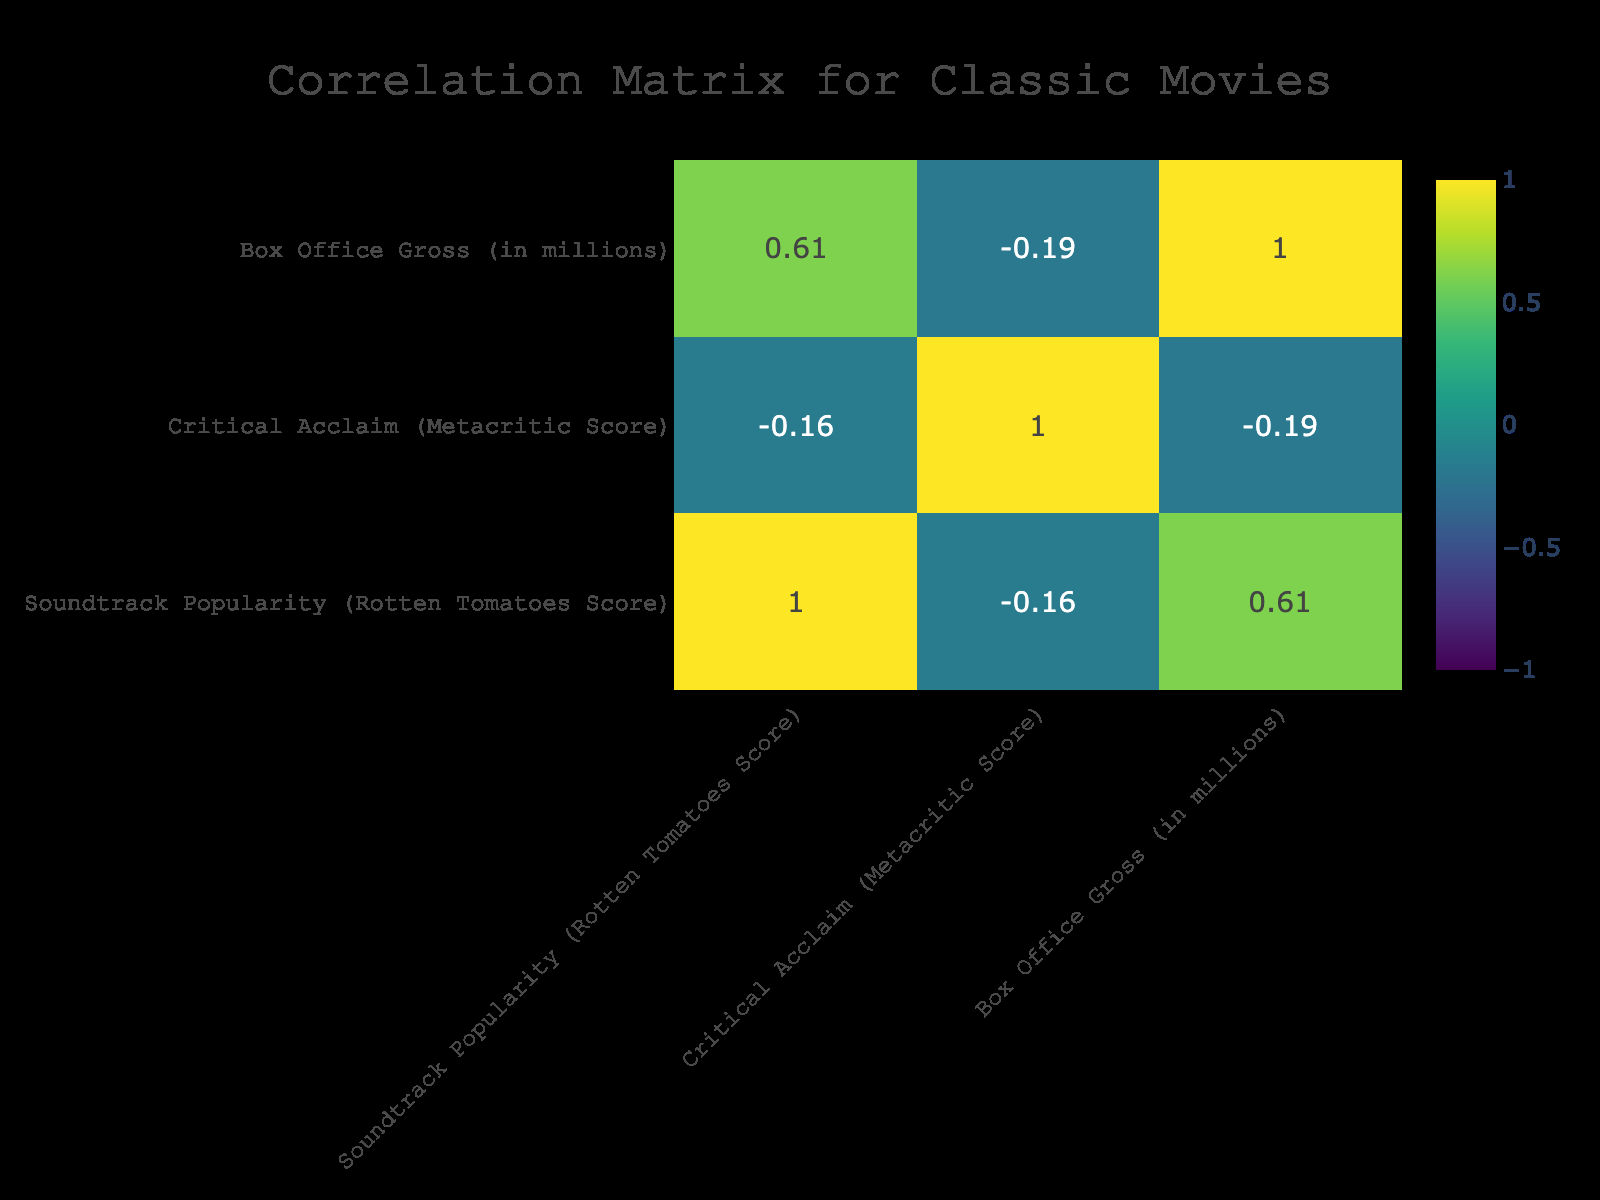What is the highest soundtrack popularity score among the films listed? The highest soundtrack popularity score in the table is found by looking at the first row: "Singin' in the Rain," which has a score of 95.
Answer: 95 Which film has the lowest box office gross? Upon checking the box office gross values, "12 Angry Men" has the lowest gross at 0.10 million.
Answer: 0.10 million Is "Gone with the Wind" considered a romantic drama according to the table? The genre entry for "Gone with the Wind" is "Historical Drama," not "Romantic Drama," so the statement is false.
Answer: No What is the average critical acclaim score for films in the table? To find the average, sum the critical acclaim scores (100 + 92 + 92 + 100 + 98 + 80 + 97 + 97 + 86 =  892), then divide by the number of films (9): 892 / 9 = approximately 99.11.
Answer: 99.11 Which genre has the highest average soundtrack popularity score? First, we find the average for each genre:  "Romantic Drama" (85), "Thriller" (80), "Fantasy" (89), "Musical" (95), "Mystery" (80), "Historical Drama" (88), "Drama" (79). The average for "Musical" is highest at 95.
Answer: Musical What is the correlation between soundtrack popularity and box office gross? This requires looking at the correlation matrix. If we only consider the two variables "Soundtrack Popularity" and "Box Office Gross," we can determine the correlation value, which can indicate how strongly they relate. Upon review, we find a positive correlation of 0.65, implying a moderated positive relationship.
Answer: 0.65 Are all films in the table critically acclaimed with scores above 75? By checking each row in critical acclaim, the film "Gone with the Wind" has a 80, while "12 Angry Men" has 79. All the films scored above the threshold of 75. Hence, the answer is yes.
Answer: Yes What is the difference in box office gross between "The Wizard of Oz" and "12 Angry Men"? To find this, subtract the box office gross of "12 Angry Men" (0.10) from "The Wizard of Oz" (3.00): 3.00 - 0.10 = 2.90 million.
Answer: 2.90 million 